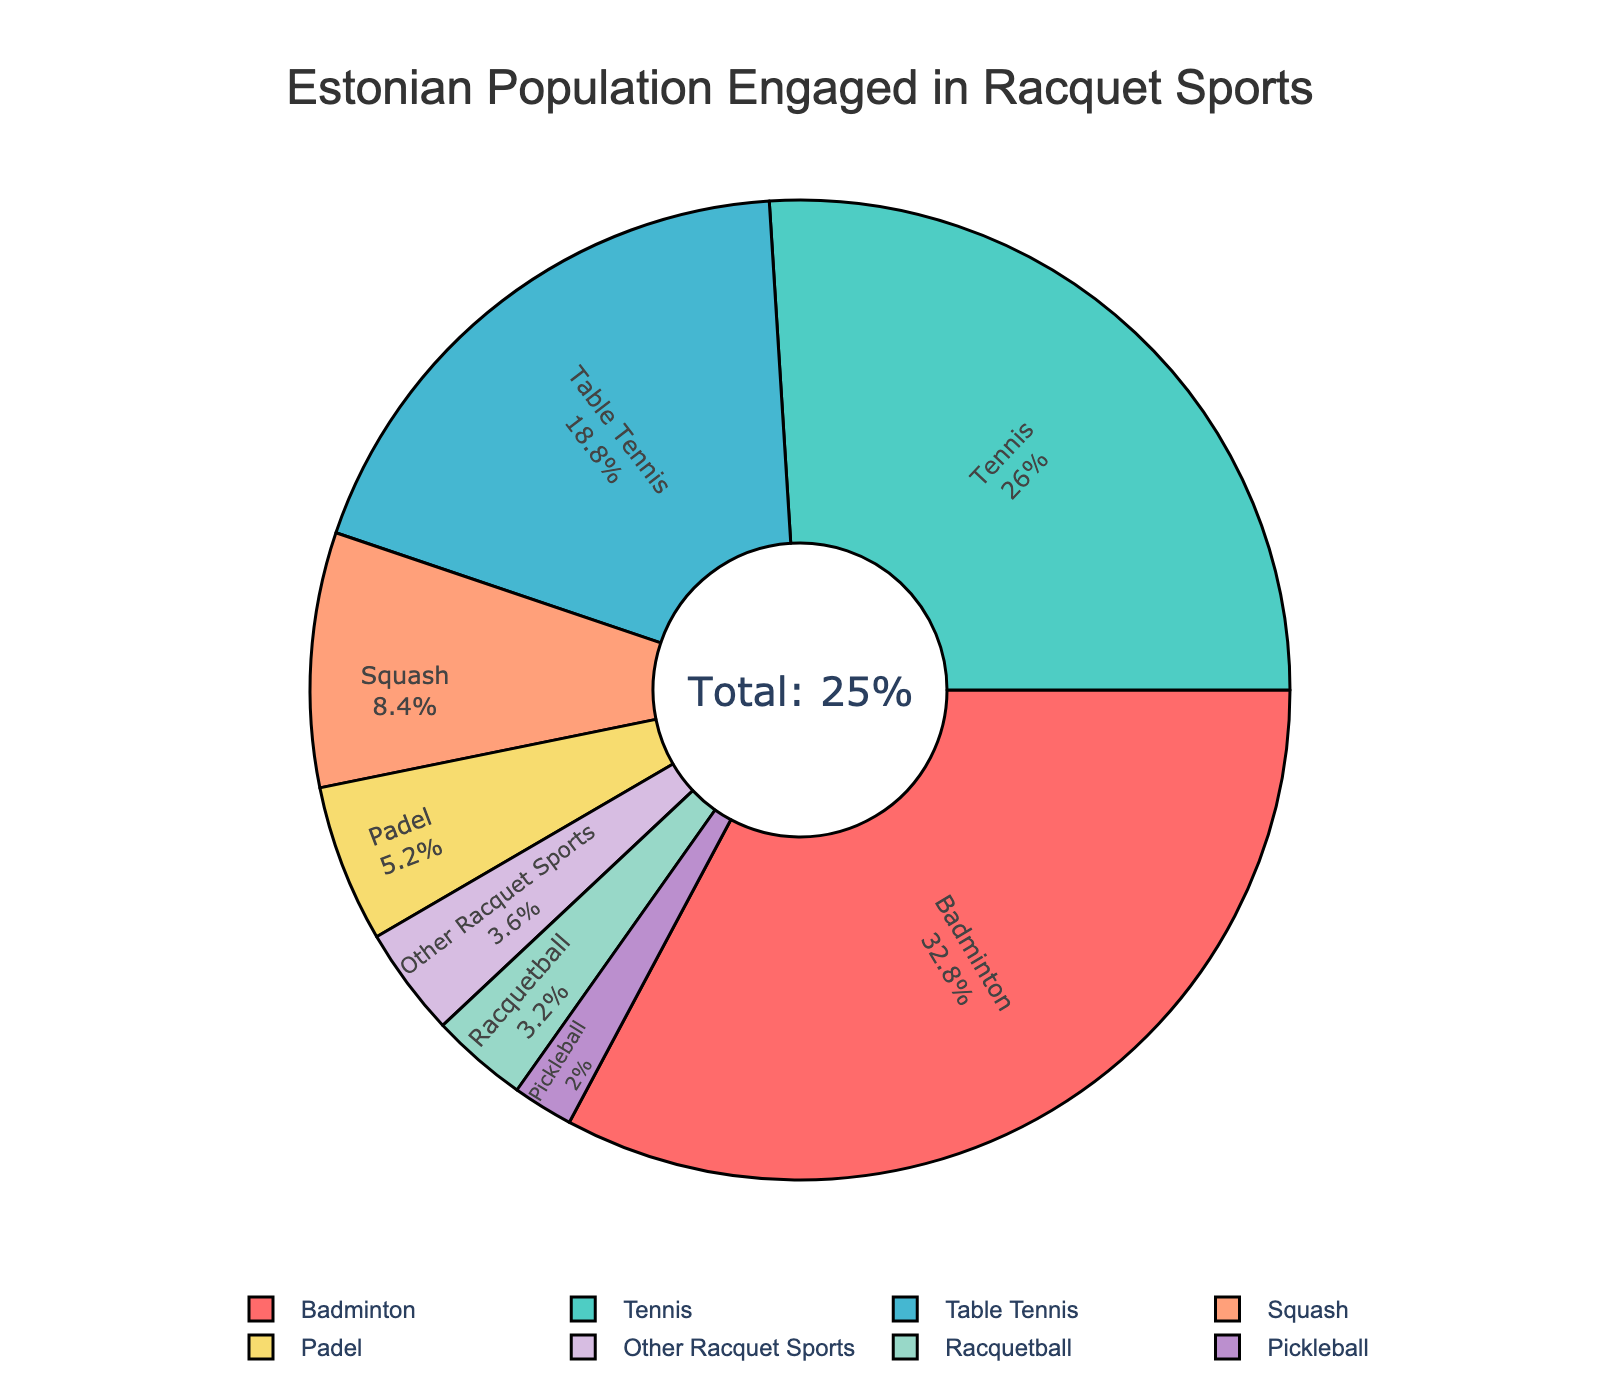What's the most popular racquet sport among the Estonian population? By referring to the pie chart, look for the sport with the largest slice of the pie. The figure shows that "Badminton" has the highest percentage.
Answer: Badminton Which racquet sport has the smallest engagement in the Estonian population? Look for the sport represented by the smallest slice of the pie. The chart indicates that "Pickleball" has the smallest percentage.
Answer: Pickleball How does the participation in Tennis compare to that in Squash? Compare the size of the slices for Tennis and Squash. Tennis has a larger slice (6.5%) than Squash (2.1%).
Answer: Tennis is more popular What is the combined percentage of people engaged in Table Tennis and Padel? Add the values of Table Tennis and Padel from the chart. Table Tennis is 4.7% and Padel is 1.3%, so 4.7 + 1.3 = 6.
Answer: 6% Is the percentage of people engaged in Badminton greater than the combined percentage of Racquetball, Padel, and Pickleball? First, sum the percentages of Racquetball, Padel, and Pickleball: 0.8 + 1.3 + 0.5 = 2.6. Then compare it to Badminton, which is 8.2%. 8.2% is greater than 2.6%.
Answer: Yes What percentage of the population is engaged in sports other than Badminton? Subtract the percentage of people engaged in Badminton from the total percentage engaging in racquet sports. The sum of all sports' percentages is 24%. 24 - 8.2 = 15.8.
Answer: 15.8% What is the visual arrangement of the labels inside the pie chart? Look at how the labels are positioned within each slice of the pie. The labels are placed inside the slices and oriented radially.
Answer: Inside and radial If you sum the percentages for Table Tennis and Squash, do they make up more or less than 10%? Add the percentages for Table Tennis (4.7%) and Squash (2.1%): 4.7 + 2.1 = 6.8%. Compare 6.8% to 10%, it is less than 10%.
Answer: Less How does Badminton's visual representation differ from Padel's in terms of color? Look at the slices for Badminton and Padel. Badminton is represented by a dark red slice, while Padel is represented by a pale greenish-blue slice.
Answer: Dark red vs pale greenish-blue 